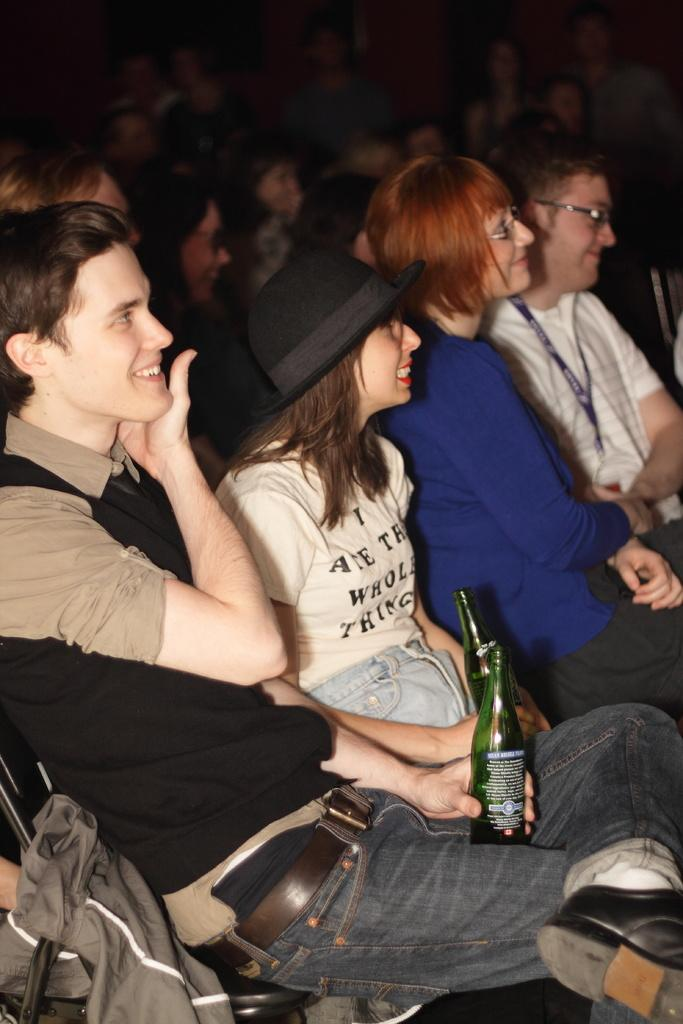What are the people in the image doing? There are people sitting in the image. Can you describe what the people in the front are holding? Two people in the front are holding bottles in their hands. What letters are visible on the bottles in the image? There is no information about letters on the bottles in the provided facts, so we cannot determine if any letters are visible. 